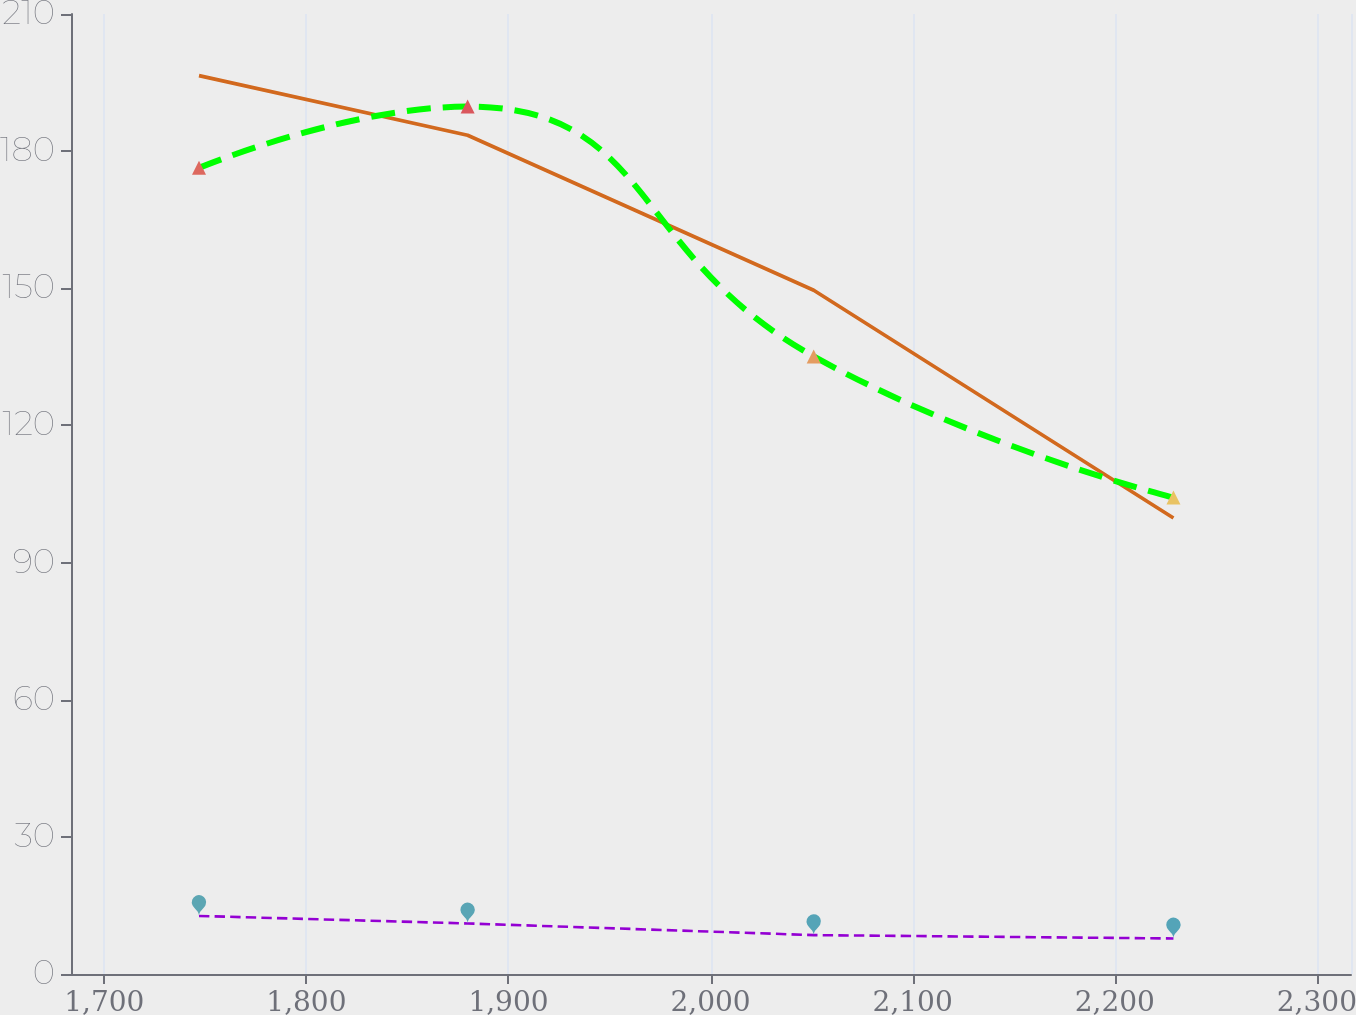Convert chart. <chart><loc_0><loc_0><loc_500><loc_500><line_chart><ecel><fcel>Sublease Rental Receipts<fcel>Net Lease Commitments<fcel>Minimum Lease Payments<nl><fcel>1746.86<fcel>196.52<fcel>12.7<fcel>176.34<nl><fcel>1879.78<fcel>183.48<fcel>11.06<fcel>189.75<nl><fcel>2051.03<fcel>149.57<fcel>8.51<fcel>135.1<nl><fcel>2229.04<fcel>99.76<fcel>7.77<fcel>104.21<nl><fcel>2380.23<fcel>77.19<fcel>5.27<fcel>77.85<nl></chart> 